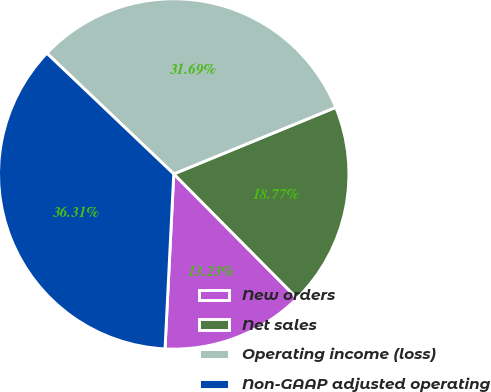Convert chart. <chart><loc_0><loc_0><loc_500><loc_500><pie_chart><fcel>New orders<fcel>Net sales<fcel>Operating income (loss)<fcel>Non-GAAP adjusted operating<nl><fcel>13.23%<fcel>18.77%<fcel>31.69%<fcel>36.31%<nl></chart> 